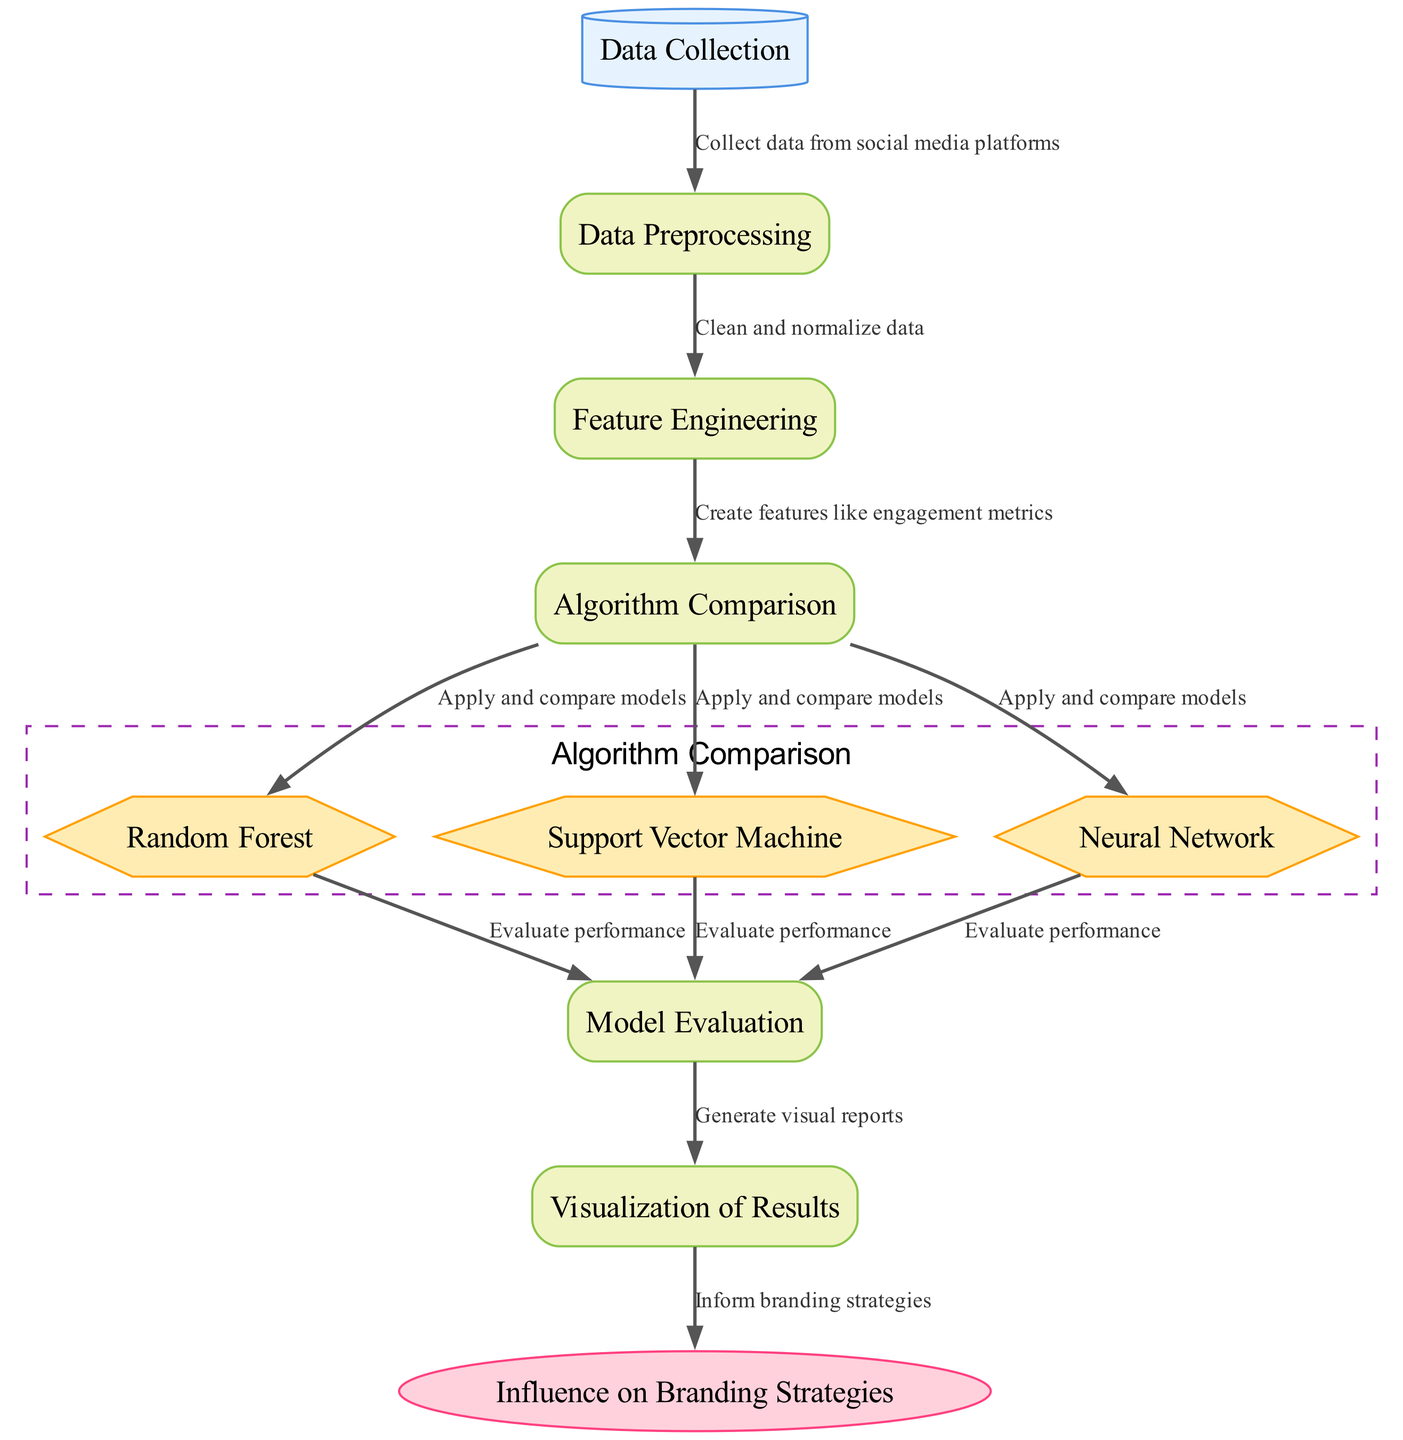What is the first step in the process? The diagram shows that the first node is "Data Collection," indicating that this is the initial step in the workflow.
Answer: Data Collection How many algorithms are compared in the diagram? There are three algorithms represented as nodes (Random Forest, Support Vector Machine, and Neural Network) under the "Algorithm Comparison" section.
Answer: 3 What type of node is "Model Evaluation"? The node "Model Evaluation" is categorized as a process, which is indicated by its rectangle shape in the diagram.
Answer: process Which process leads to the "Visualization of Results"? The "Model Evaluation" node is the process that directly leads to the "Visualization of Results" node, as indicated by the connecting edge.
Answer: Model Evaluation What is created during the "Feature Engineering" phase? In the "Feature Engineering" phase, the diagram states "Create features like engagement metrics," explaining what is accomplished in this step.
Answer: features like engagement metrics Which algorithms have a direct data flow to "Model Evaluation"? The data flows from Random Forest, Support Vector Machine, and Neural Network nodes to the "Model Evaluation" node as indicated by the edges connecting these nodes.
Answer: Random Forest, Support Vector Machine, Neural Network How does the diagram show the relationship between "Visualization of Results" and "Influence on Branding Strategies"? The diagram illustrates a direct flow from the "Visualization of Results" to "Influence on Branding Strategies," meaning that the insights generated from the visualization inform branding decisions.
Answer: direct flow What type of diagram is represented here? The diagram is a Machine Learning Diagram, as stated in the comment section of the code that generates it, focusing on predictive analytics.
Answer: Machine Learning Diagram 